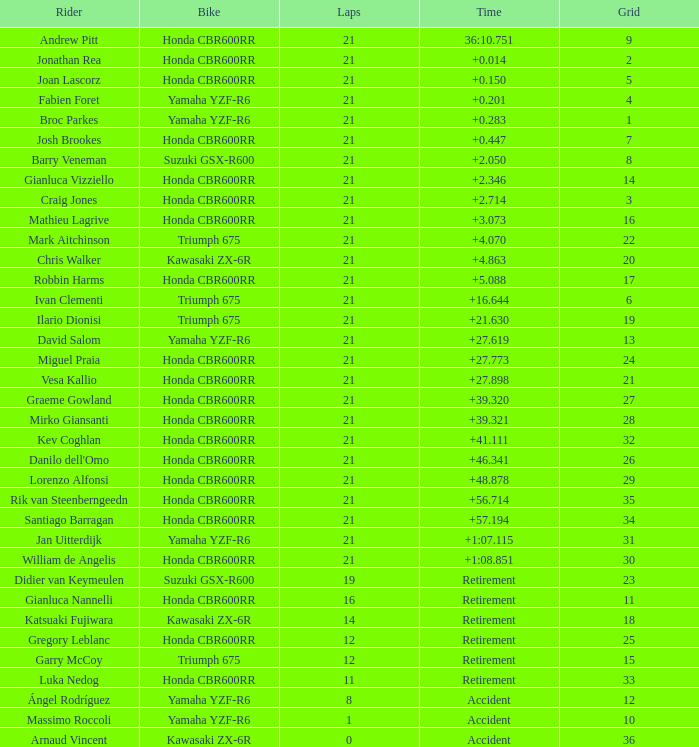What is the overall sum of laps driven by the driver with a grid lesser than 17 and a time of + None. Would you be able to parse every entry in this table? {'header': ['Rider', 'Bike', 'Laps', 'Time', 'Grid'], 'rows': [['Andrew Pitt', 'Honda CBR600RR', '21', '36:10.751', '9'], ['Jonathan Rea', 'Honda CBR600RR', '21', '+0.014', '2'], ['Joan Lascorz', 'Honda CBR600RR', '21', '+0.150', '5'], ['Fabien Foret', 'Yamaha YZF-R6', '21', '+0.201', '4'], ['Broc Parkes', 'Yamaha YZF-R6', '21', '+0.283', '1'], ['Josh Brookes', 'Honda CBR600RR', '21', '+0.447', '7'], ['Barry Veneman', 'Suzuki GSX-R600', '21', '+2.050', '8'], ['Gianluca Vizziello', 'Honda CBR600RR', '21', '+2.346', '14'], ['Craig Jones', 'Honda CBR600RR', '21', '+2.714', '3'], ['Mathieu Lagrive', 'Honda CBR600RR', '21', '+3.073', '16'], ['Mark Aitchinson', 'Triumph 675', '21', '+4.070', '22'], ['Chris Walker', 'Kawasaki ZX-6R', '21', '+4.863', '20'], ['Robbin Harms', 'Honda CBR600RR', '21', '+5.088', '17'], ['Ivan Clementi', 'Triumph 675', '21', '+16.644', '6'], ['Ilario Dionisi', 'Triumph 675', '21', '+21.630', '19'], ['David Salom', 'Yamaha YZF-R6', '21', '+27.619', '13'], ['Miguel Praia', 'Honda CBR600RR', '21', '+27.773', '24'], ['Vesa Kallio', 'Honda CBR600RR', '21', '+27.898', '21'], ['Graeme Gowland', 'Honda CBR600RR', '21', '+39.320', '27'], ['Mirko Giansanti', 'Honda CBR600RR', '21', '+39.321', '28'], ['Kev Coghlan', 'Honda CBR600RR', '21', '+41.111', '32'], ["Danilo dell'Omo", 'Honda CBR600RR', '21', '+46.341', '26'], ['Lorenzo Alfonsi', 'Honda CBR600RR', '21', '+48.878', '29'], ['Rik van Steenberngeedn', 'Honda CBR600RR', '21', '+56.714', '35'], ['Santiago Barragan', 'Honda CBR600RR', '21', '+57.194', '34'], ['Jan Uitterdijk', 'Yamaha YZF-R6', '21', '+1:07.115', '31'], ['William de Angelis', 'Honda CBR600RR', '21', '+1:08.851', '30'], ['Didier van Keymeulen', 'Suzuki GSX-R600', '19', 'Retirement', '23'], ['Gianluca Nannelli', 'Honda CBR600RR', '16', 'Retirement', '11'], ['Katsuaki Fujiwara', 'Kawasaki ZX-6R', '14', 'Retirement', '18'], ['Gregory Leblanc', 'Honda CBR600RR', '12', 'Retirement', '25'], ['Garry McCoy', 'Triumph 675', '12', 'Retirement', '15'], ['Luka Nedog', 'Honda CBR600RR', '11', 'Retirement', '33'], ['Ángel Rodríguez', 'Yamaha YZF-R6', '8', 'Accident', '12'], ['Massimo Roccoli', 'Yamaha YZF-R6', '1', 'Accident', '10'], ['Arnaud Vincent', 'Kawasaki ZX-6R', '0', 'Accident', '36']]} 